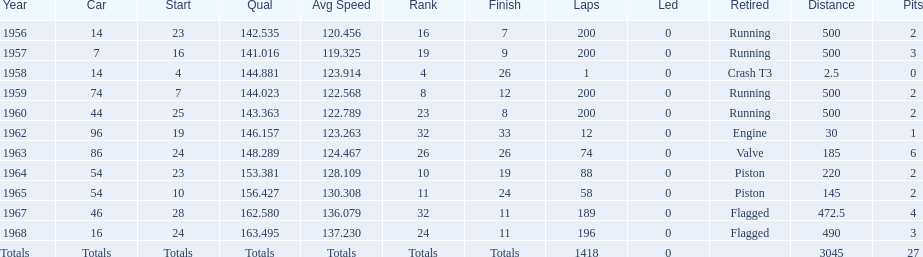Tell me the number of times he finished above 10th place. 3. 